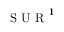<formula> <loc_0><loc_0><loc_500><loc_500>{ S U R ^ { 1 } }</formula> 